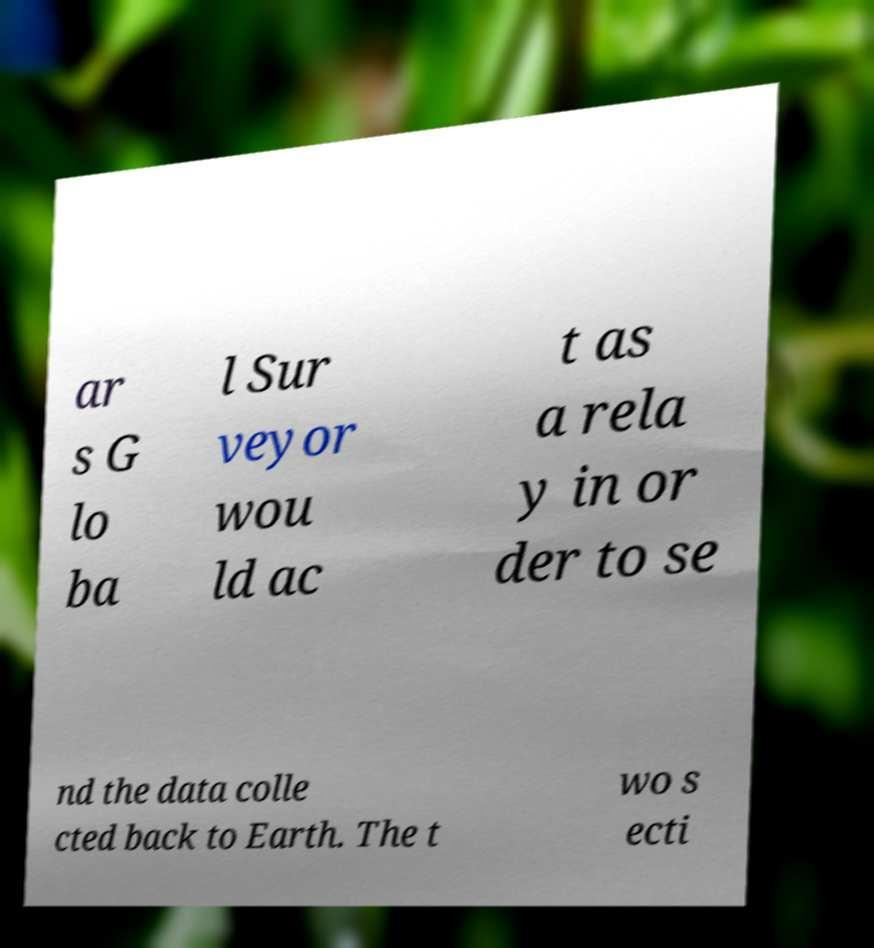Could you extract and type out the text from this image? ar s G lo ba l Sur veyor wou ld ac t as a rela y in or der to se nd the data colle cted back to Earth. The t wo s ecti 